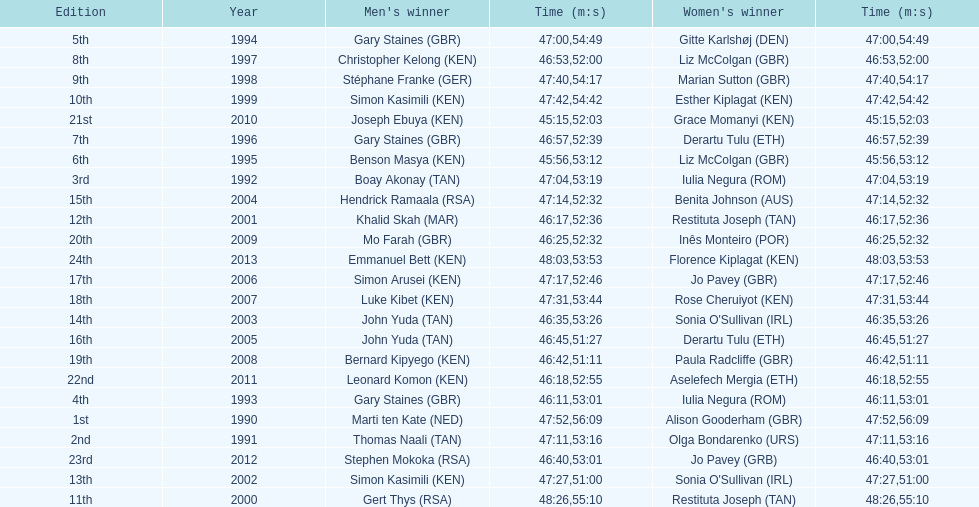The other women's winner with the same finish time as jo pavey in 2012 Iulia Negura. 